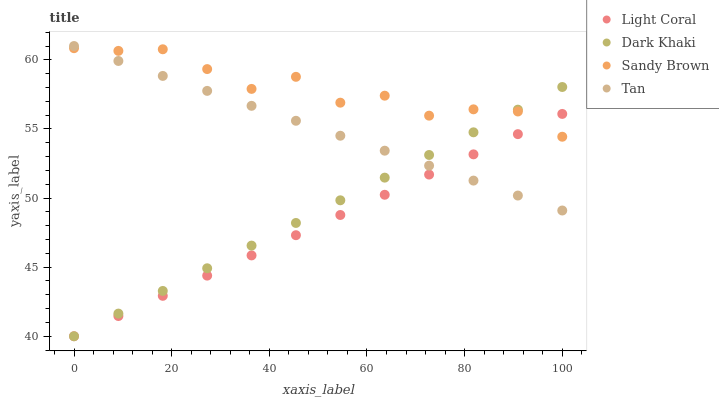Does Light Coral have the minimum area under the curve?
Answer yes or no. Yes. Does Sandy Brown have the maximum area under the curve?
Answer yes or no. Yes. Does Dark Khaki have the minimum area under the curve?
Answer yes or no. No. Does Dark Khaki have the maximum area under the curve?
Answer yes or no. No. Is Tan the smoothest?
Answer yes or no. Yes. Is Sandy Brown the roughest?
Answer yes or no. Yes. Is Dark Khaki the smoothest?
Answer yes or no. No. Is Dark Khaki the roughest?
Answer yes or no. No. Does Light Coral have the lowest value?
Answer yes or no. Yes. Does Tan have the lowest value?
Answer yes or no. No. Does Tan have the highest value?
Answer yes or no. Yes. Does Dark Khaki have the highest value?
Answer yes or no. No. Does Light Coral intersect Sandy Brown?
Answer yes or no. Yes. Is Light Coral less than Sandy Brown?
Answer yes or no. No. Is Light Coral greater than Sandy Brown?
Answer yes or no. No. 